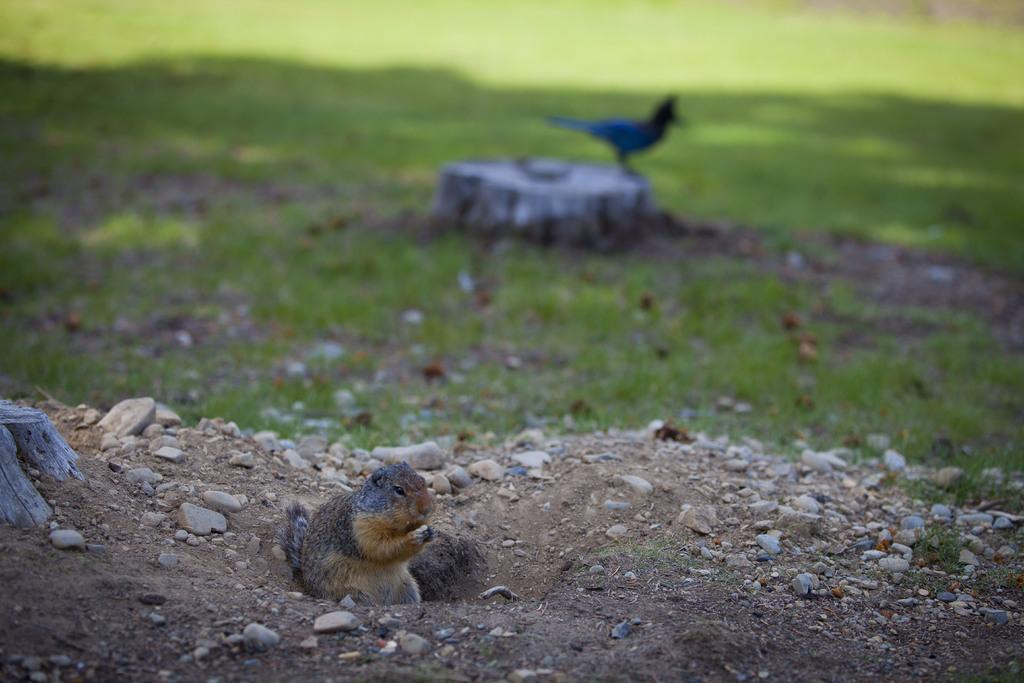What type of animal can be seen in the image? There is a bird and a squirrel in the image. What type of natural environment is visible in the image? There are stones and grass visible in the image. What type of brush is the bird using to start painting in the image? There is no brush or painting activity present in the image; it features a bird and a squirrel in a natural environment. 